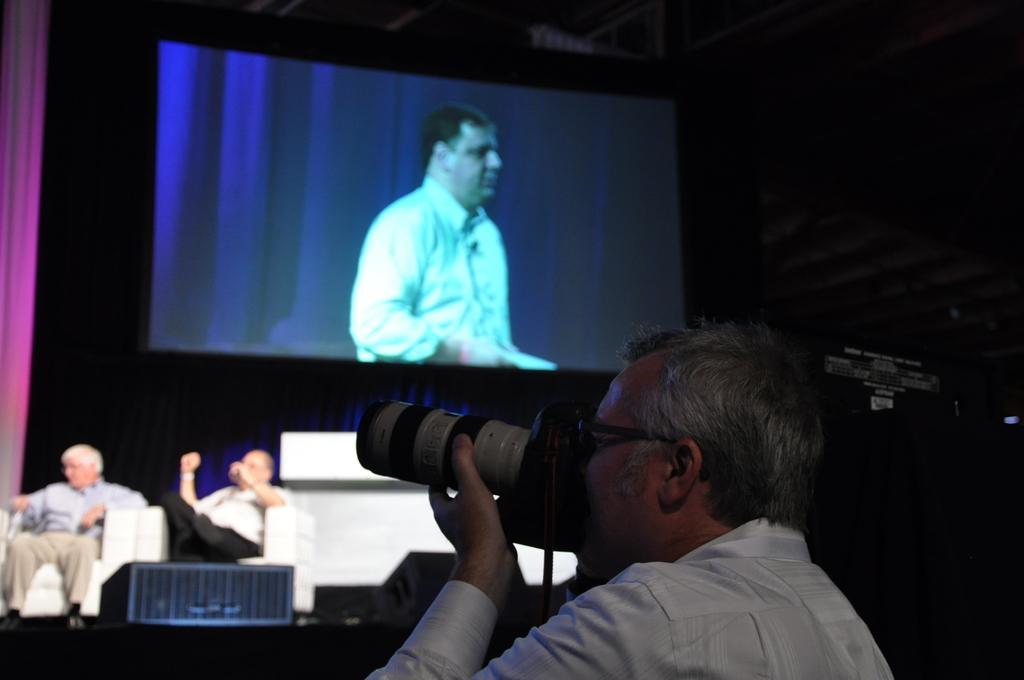Could you give a brief overview of what you see in this image? It is a conference two men are sitting on the sofa on the dais and behind them there is a projector screen and some image is being projected on the screen,in the front a man is standing and taking the photographs. 